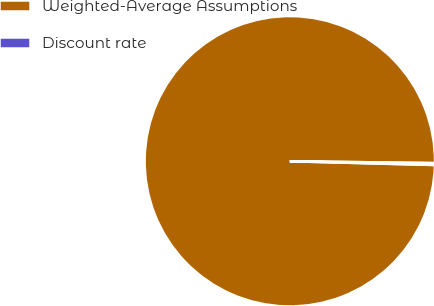Convert chart to OTSL. <chart><loc_0><loc_0><loc_500><loc_500><pie_chart><fcel>Weighted-Average Assumptions<fcel>Discount rate<nl><fcel>99.79%<fcel>0.21%<nl></chart> 